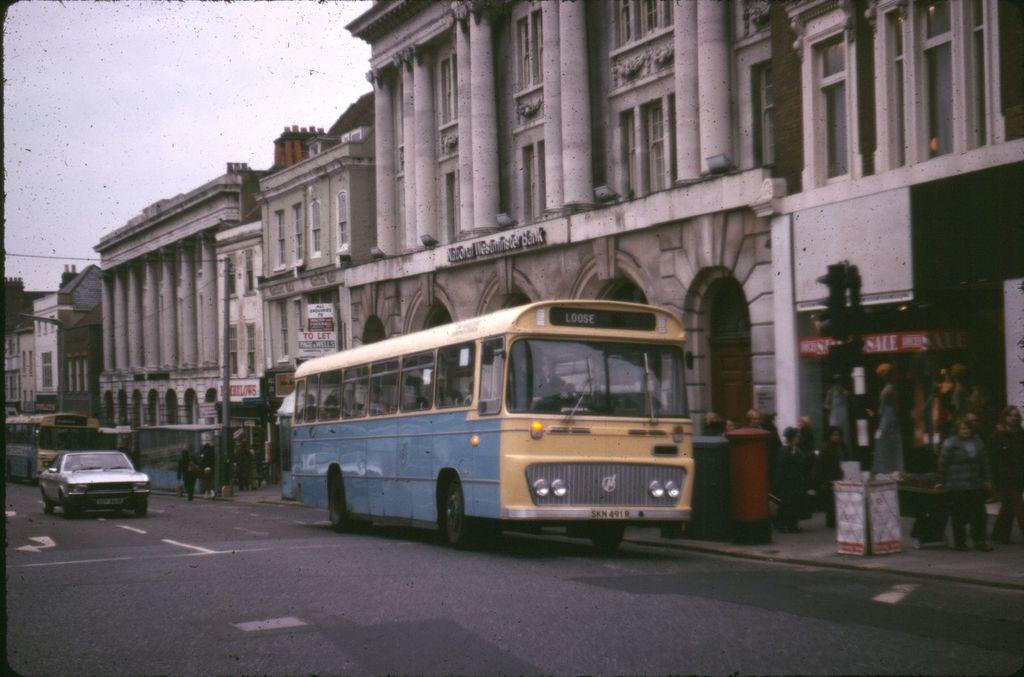Please provide a concise description of this image. In this picture we can see a car, buses on the road, buildings, poles, posters, some objects and a group of people on the footpath and in the background we can see the sky. 